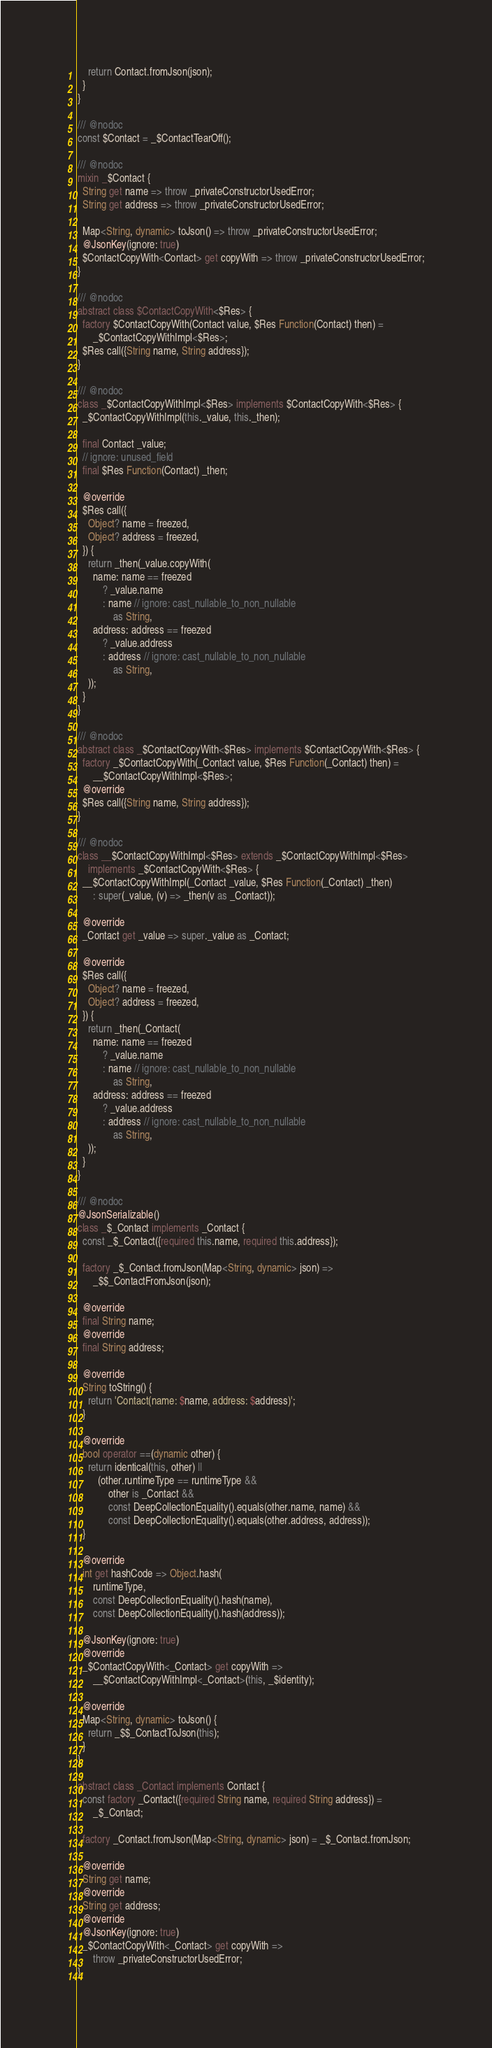Convert code to text. <code><loc_0><loc_0><loc_500><loc_500><_Dart_>    return Contact.fromJson(json);
  }
}

/// @nodoc
const $Contact = _$ContactTearOff();

/// @nodoc
mixin _$Contact {
  String get name => throw _privateConstructorUsedError;
  String get address => throw _privateConstructorUsedError;

  Map<String, dynamic> toJson() => throw _privateConstructorUsedError;
  @JsonKey(ignore: true)
  $ContactCopyWith<Contact> get copyWith => throw _privateConstructorUsedError;
}

/// @nodoc
abstract class $ContactCopyWith<$Res> {
  factory $ContactCopyWith(Contact value, $Res Function(Contact) then) =
      _$ContactCopyWithImpl<$Res>;
  $Res call({String name, String address});
}

/// @nodoc
class _$ContactCopyWithImpl<$Res> implements $ContactCopyWith<$Res> {
  _$ContactCopyWithImpl(this._value, this._then);

  final Contact _value;
  // ignore: unused_field
  final $Res Function(Contact) _then;

  @override
  $Res call({
    Object? name = freezed,
    Object? address = freezed,
  }) {
    return _then(_value.copyWith(
      name: name == freezed
          ? _value.name
          : name // ignore: cast_nullable_to_non_nullable
              as String,
      address: address == freezed
          ? _value.address
          : address // ignore: cast_nullable_to_non_nullable
              as String,
    ));
  }
}

/// @nodoc
abstract class _$ContactCopyWith<$Res> implements $ContactCopyWith<$Res> {
  factory _$ContactCopyWith(_Contact value, $Res Function(_Contact) then) =
      __$ContactCopyWithImpl<$Res>;
  @override
  $Res call({String name, String address});
}

/// @nodoc
class __$ContactCopyWithImpl<$Res> extends _$ContactCopyWithImpl<$Res>
    implements _$ContactCopyWith<$Res> {
  __$ContactCopyWithImpl(_Contact _value, $Res Function(_Contact) _then)
      : super(_value, (v) => _then(v as _Contact));

  @override
  _Contact get _value => super._value as _Contact;

  @override
  $Res call({
    Object? name = freezed,
    Object? address = freezed,
  }) {
    return _then(_Contact(
      name: name == freezed
          ? _value.name
          : name // ignore: cast_nullable_to_non_nullable
              as String,
      address: address == freezed
          ? _value.address
          : address // ignore: cast_nullable_to_non_nullable
              as String,
    ));
  }
}

/// @nodoc
@JsonSerializable()
class _$_Contact implements _Contact {
  const _$_Contact({required this.name, required this.address});

  factory _$_Contact.fromJson(Map<String, dynamic> json) =>
      _$$_ContactFromJson(json);

  @override
  final String name;
  @override
  final String address;

  @override
  String toString() {
    return 'Contact(name: $name, address: $address)';
  }

  @override
  bool operator ==(dynamic other) {
    return identical(this, other) ||
        (other.runtimeType == runtimeType &&
            other is _Contact &&
            const DeepCollectionEquality().equals(other.name, name) &&
            const DeepCollectionEquality().equals(other.address, address));
  }

  @override
  int get hashCode => Object.hash(
      runtimeType,
      const DeepCollectionEquality().hash(name),
      const DeepCollectionEquality().hash(address));

  @JsonKey(ignore: true)
  @override
  _$ContactCopyWith<_Contact> get copyWith =>
      __$ContactCopyWithImpl<_Contact>(this, _$identity);

  @override
  Map<String, dynamic> toJson() {
    return _$$_ContactToJson(this);
  }
}

abstract class _Contact implements Contact {
  const factory _Contact({required String name, required String address}) =
      _$_Contact;

  factory _Contact.fromJson(Map<String, dynamic> json) = _$_Contact.fromJson;

  @override
  String get name;
  @override
  String get address;
  @override
  @JsonKey(ignore: true)
  _$ContactCopyWith<_Contact> get copyWith =>
      throw _privateConstructorUsedError;
}
</code> 